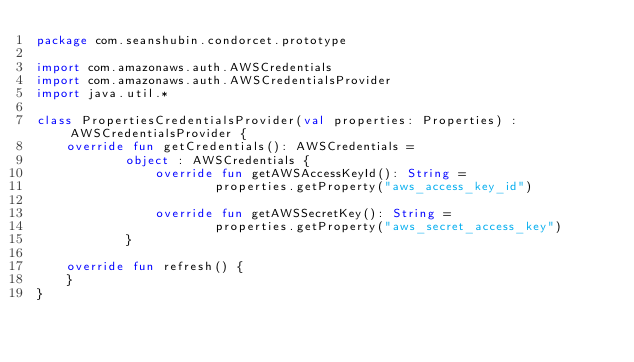Convert code to text. <code><loc_0><loc_0><loc_500><loc_500><_Kotlin_>package com.seanshubin.condorcet.prototype

import com.amazonaws.auth.AWSCredentials
import com.amazonaws.auth.AWSCredentialsProvider
import java.util.*

class PropertiesCredentialsProvider(val properties: Properties) : AWSCredentialsProvider {
    override fun getCredentials(): AWSCredentials =
            object : AWSCredentials {
                override fun getAWSAccessKeyId(): String =
                        properties.getProperty("aws_access_key_id")

                override fun getAWSSecretKey(): String =
                        properties.getProperty("aws_secret_access_key")
            }

    override fun refresh() {
    }
}
</code> 